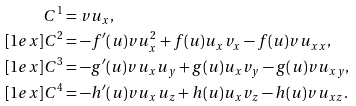Convert formula to latex. <formula><loc_0><loc_0><loc_500><loc_500>C ^ { 1 } & = v u _ { x } , \\ [ 1 e x ] C ^ { 2 } & = - f ^ { \prime } ( u ) v u _ { x } ^ { 2 } + f ( u ) u _ { x } v _ { x } - f ( u ) v u _ { x x } , \\ [ 1 e x ] C ^ { 3 } & = - g ^ { \prime } ( u ) v u _ { x } u _ { y } + g ( u ) u _ { x } v _ { y } - g ( u ) v u _ { x y } , \\ [ 1 e x ] C ^ { 4 } & = - h ^ { \prime } ( u ) v u _ { x } u _ { z } + h ( u ) u _ { x } v _ { z } - h ( u ) v u _ { x z } .</formula> 